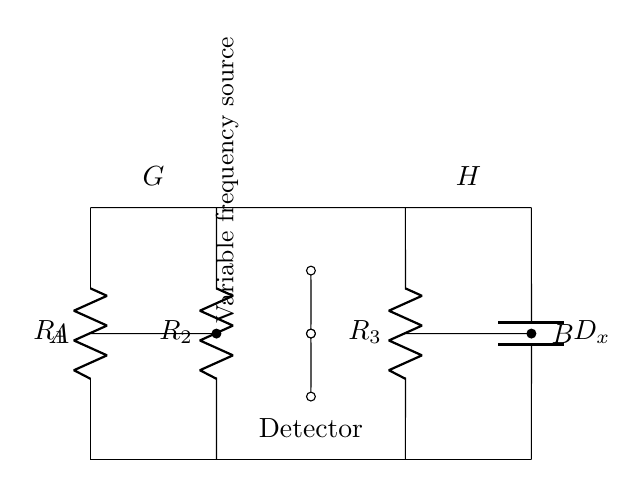What are the components used in this bridge circuit? The components are three resistors and one capacitor. The resistors are labeled R1, R2, and R3, and the capacitor is labeled Cx.
Answer: Three resistors and one capacitor What does the symbol "C" represent in the circuit? The symbol "C" represents a capacitor, specifically the component labeled Cx which measures capacitance.
Answer: Capacitor What is the role of D_x in this circuit? D_x represents the dissipation factor of the capacitor, which is an indication of energy loss in the capacitor during operation.
Answer: Dissipation factor Which elements are connected in series? Elements R1, R2, and R3 are connected in series between the upper and lower rails of the bridge circuit.
Answer: R1, R2, R3 What is the function of the variable frequency source? The variable frequency source is used to supply alternating current to the circuit, allowing for the measurement of capacitance and dissipation factor at different frequencies.
Answer: Supply alternating current How do the nodes A and B interact in this bridge circuit? Nodes A and B form a Wheatstone-like balance point where the net current can be measured to identify the balance of the bridge, indicating a precise measurement condition.
Answer: They form a balance point What is the purpose of the detector in the circuit? The detector is used to measure the current flowing between points A and B, assisting in the assessment of the balance in the circuit and through this, determining component values.
Answer: Measure current between A and B 